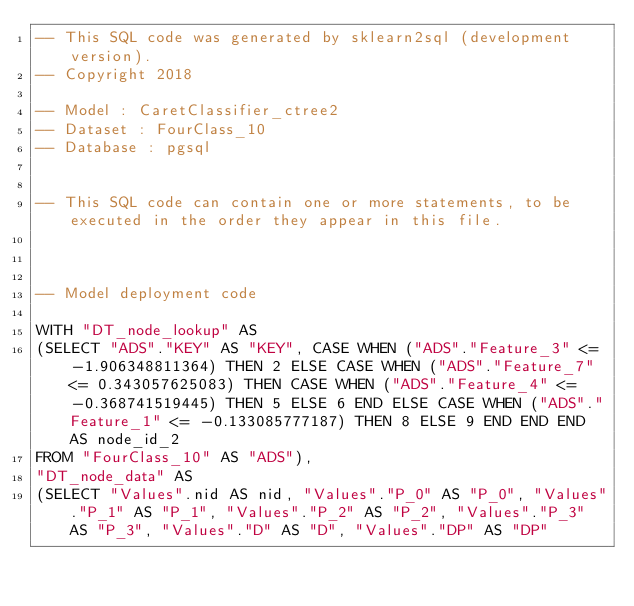<code> <loc_0><loc_0><loc_500><loc_500><_SQL_>-- This SQL code was generated by sklearn2sql (development version).
-- Copyright 2018

-- Model : CaretClassifier_ctree2
-- Dataset : FourClass_10
-- Database : pgsql


-- This SQL code can contain one or more statements, to be executed in the order they appear in this file.



-- Model deployment code

WITH "DT_node_lookup" AS 
(SELECT "ADS"."KEY" AS "KEY", CASE WHEN ("ADS"."Feature_3" <= -1.906348811364) THEN 2 ELSE CASE WHEN ("ADS"."Feature_7" <= 0.343057625083) THEN CASE WHEN ("ADS"."Feature_4" <= -0.368741519445) THEN 5 ELSE 6 END ELSE CASE WHEN ("ADS"."Feature_1" <= -0.133085777187) THEN 8 ELSE 9 END END END AS node_id_2 
FROM "FourClass_10" AS "ADS"), 
"DT_node_data" AS 
(SELECT "Values".nid AS nid, "Values"."P_0" AS "P_0", "Values"."P_1" AS "P_1", "Values"."P_2" AS "P_2", "Values"."P_3" AS "P_3", "Values"."D" AS "D", "Values"."DP" AS "DP" </code> 